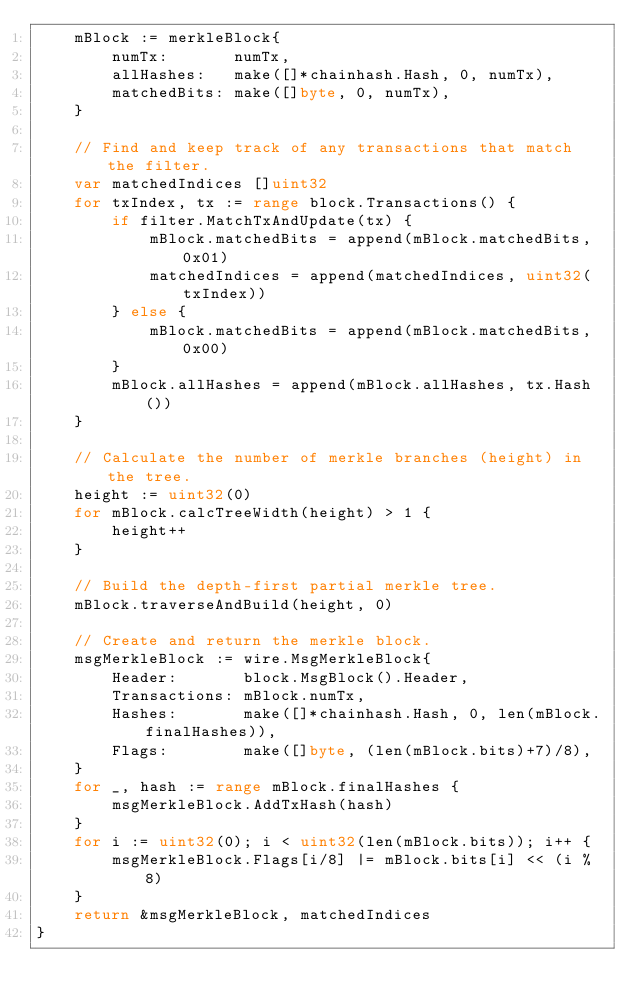Convert code to text. <code><loc_0><loc_0><loc_500><loc_500><_Go_>	mBlock := merkleBlock{
		numTx:       numTx,
		allHashes:   make([]*chainhash.Hash, 0, numTx),
		matchedBits: make([]byte, 0, numTx),
	}

	// Find and keep track of any transactions that match the filter.
	var matchedIndices []uint32
	for txIndex, tx := range block.Transactions() {
		if filter.MatchTxAndUpdate(tx) {
			mBlock.matchedBits = append(mBlock.matchedBits, 0x01)
			matchedIndices = append(matchedIndices, uint32(txIndex))
		} else {
			mBlock.matchedBits = append(mBlock.matchedBits, 0x00)
		}
		mBlock.allHashes = append(mBlock.allHashes, tx.Hash())
	}

	// Calculate the number of merkle branches (height) in the tree.
	height := uint32(0)
	for mBlock.calcTreeWidth(height) > 1 {
		height++
	}

	// Build the depth-first partial merkle tree.
	mBlock.traverseAndBuild(height, 0)

	// Create and return the merkle block.
	msgMerkleBlock := wire.MsgMerkleBlock{
		Header:       block.MsgBlock().Header,
		Transactions: mBlock.numTx,
		Hashes:       make([]*chainhash.Hash, 0, len(mBlock.finalHashes)),
		Flags:        make([]byte, (len(mBlock.bits)+7)/8),
	}
	for _, hash := range mBlock.finalHashes {
		msgMerkleBlock.AddTxHash(hash)
	}
	for i := uint32(0); i < uint32(len(mBlock.bits)); i++ {
		msgMerkleBlock.Flags[i/8] |= mBlock.bits[i] << (i % 8)
	}
	return &msgMerkleBlock, matchedIndices
}
</code> 